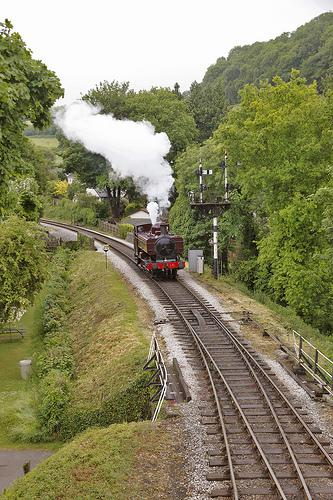Question: where is the bridge?
Choices:
A. Over the river.
B. Over the stream.
C. Behind the train.
D. Over the gully.
Answer with the letter. Answer: C Question: what is on both sides of the track?
Choices:
A. Gravel.
B. Grass.
C. Weeds.
D. Dirt.
Answer with the letter. Answer: A Question: what has red on the front?
Choices:
A. Truck.
B. Train.
C. Car.
D. Boat.
Answer with the letter. Answer: B Question: where was the photo taken?
Choices:
A. At the bus stop.
B. At the airport.
C. At the beach.
D. On a train track.
Answer with the letter. Answer: D 